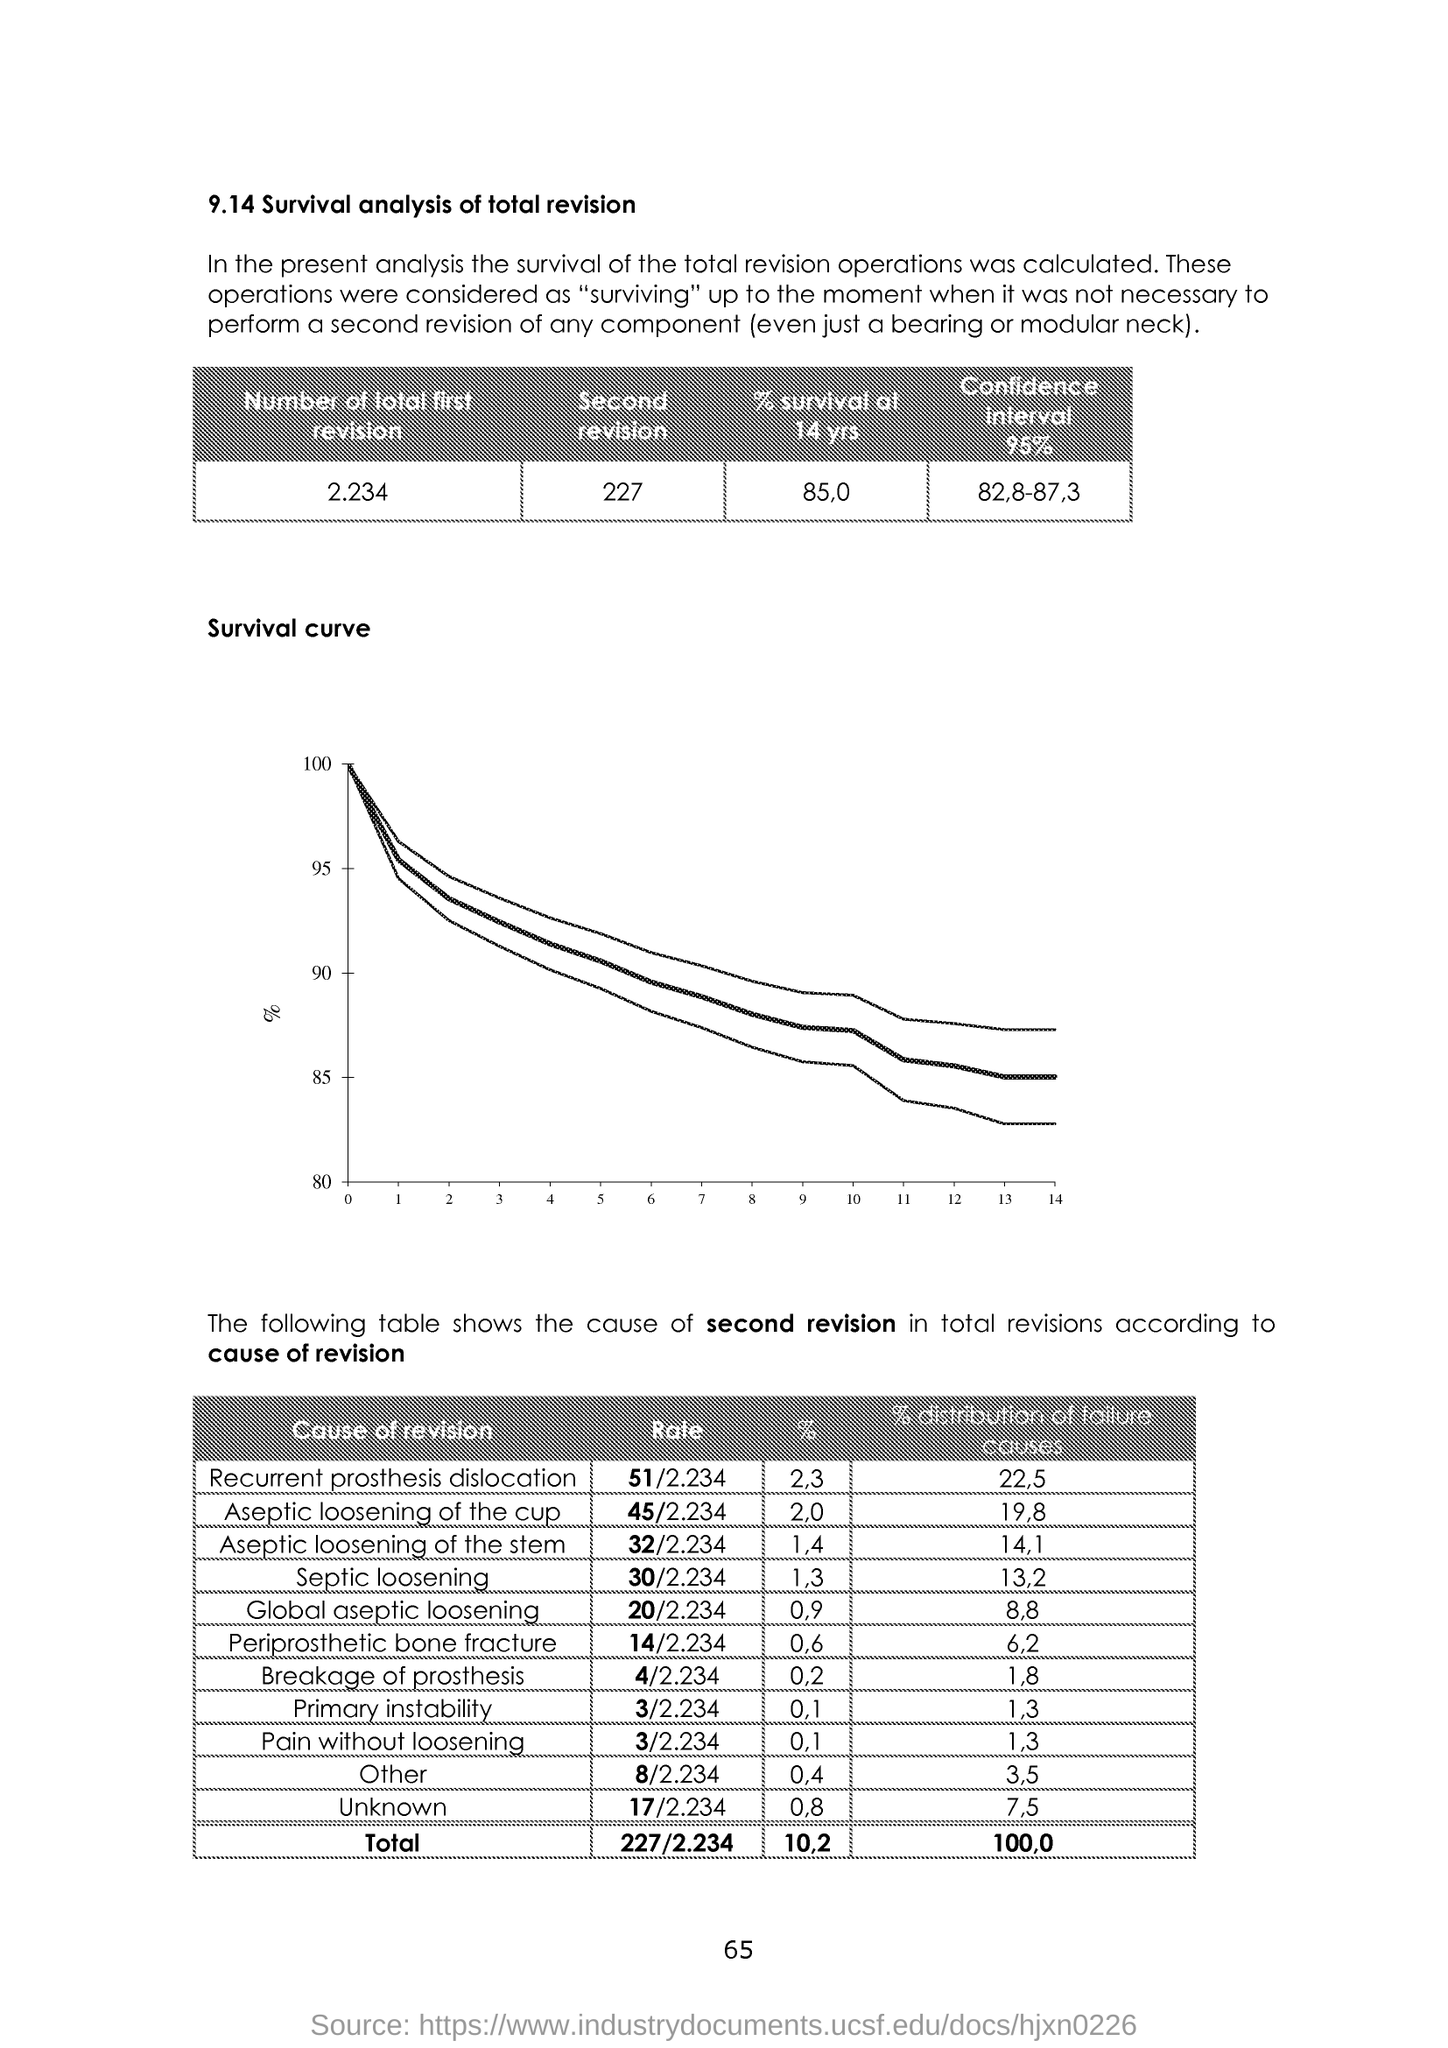What is the Number of total first revision?
Provide a succinct answer. 2.234. What is the Number of total second revision?
Give a very brief answer. 227. What is the % survival of 14 yrs?
Offer a very short reply. 85,0. What is the confidence interval 95%?
Your answer should be very brief. 82,8-87,3. What is the % of recurrent prosthesis dislocation?
Your answer should be compact. 2,3. What is the % of Aseptic loosening of cup?
Provide a succinct answer. 2.0. What is the % of septic loosening?
Keep it short and to the point. 1.3. What is the % of global aseptic loosening?
Your response must be concise. 0.9. What is the % of periprosthetic bone fracture?
Give a very brief answer. 0.6. 